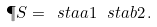Convert formula to latex. <formula><loc_0><loc_0><loc_500><loc_500>\P S = \ s t a { a } { 1 } \, \ s t a { b } { 2 } \, .</formula> 